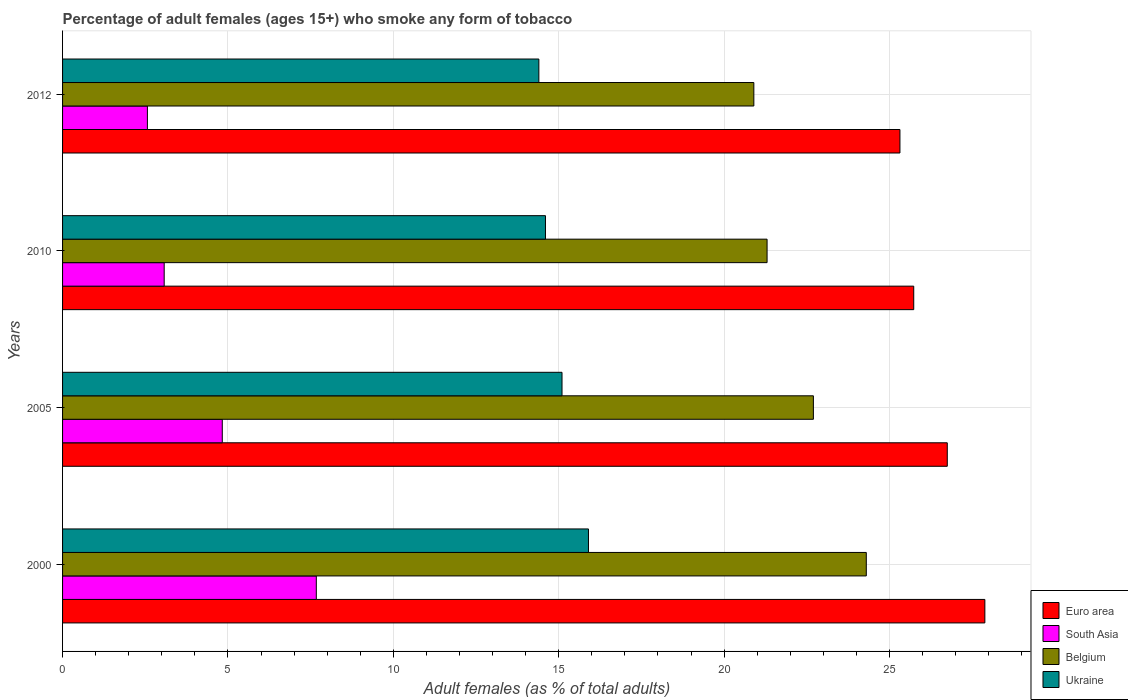How many different coloured bars are there?
Give a very brief answer. 4. How many groups of bars are there?
Offer a very short reply. 4. Are the number of bars per tick equal to the number of legend labels?
Provide a short and direct response. Yes. How many bars are there on the 3rd tick from the top?
Provide a succinct answer. 4. What is the label of the 4th group of bars from the top?
Provide a short and direct response. 2000. What is the percentage of adult females who smoke in Ukraine in 2012?
Provide a short and direct response. 14.4. Across all years, what is the maximum percentage of adult females who smoke in Belgium?
Your answer should be very brief. 24.3. In which year was the percentage of adult females who smoke in Belgium minimum?
Your answer should be compact. 2012. What is the difference between the percentage of adult females who smoke in Belgium in 2010 and the percentage of adult females who smoke in South Asia in 2005?
Your response must be concise. 16.47. What is the average percentage of adult females who smoke in Belgium per year?
Ensure brevity in your answer.  22.3. In the year 2000, what is the difference between the percentage of adult females who smoke in Belgium and percentage of adult females who smoke in South Asia?
Provide a succinct answer. 16.63. What is the ratio of the percentage of adult females who smoke in Ukraine in 2000 to that in 2005?
Offer a terse response. 1.05. Is the percentage of adult females who smoke in Euro area in 2000 less than that in 2012?
Provide a succinct answer. No. What is the difference between the highest and the second highest percentage of adult females who smoke in Euro area?
Give a very brief answer. 1.14. What is the difference between the highest and the lowest percentage of adult females who smoke in Belgium?
Your response must be concise. 3.4. In how many years, is the percentage of adult females who smoke in South Asia greater than the average percentage of adult females who smoke in South Asia taken over all years?
Your answer should be very brief. 2. Is the sum of the percentage of adult females who smoke in South Asia in 2005 and 2012 greater than the maximum percentage of adult females who smoke in Euro area across all years?
Give a very brief answer. No. What does the 3rd bar from the top in 2000 represents?
Your answer should be compact. South Asia. Is it the case that in every year, the sum of the percentage of adult females who smoke in Ukraine and percentage of adult females who smoke in Belgium is greater than the percentage of adult females who smoke in Euro area?
Offer a very short reply. Yes. How many bars are there?
Your answer should be very brief. 16. Are all the bars in the graph horizontal?
Make the answer very short. Yes. What is the difference between two consecutive major ticks on the X-axis?
Provide a short and direct response. 5. Are the values on the major ticks of X-axis written in scientific E-notation?
Your answer should be compact. No. Does the graph contain any zero values?
Ensure brevity in your answer.  No. Does the graph contain grids?
Offer a very short reply. Yes. Where does the legend appear in the graph?
Your answer should be compact. Bottom right. How are the legend labels stacked?
Ensure brevity in your answer.  Vertical. What is the title of the graph?
Keep it short and to the point. Percentage of adult females (ages 15+) who smoke any form of tobacco. Does "Bosnia and Herzegovina" appear as one of the legend labels in the graph?
Your answer should be compact. No. What is the label or title of the X-axis?
Ensure brevity in your answer.  Adult females (as % of total adults). What is the Adult females (as % of total adults) in Euro area in 2000?
Ensure brevity in your answer.  27.88. What is the Adult females (as % of total adults) in South Asia in 2000?
Provide a succinct answer. 7.67. What is the Adult females (as % of total adults) in Belgium in 2000?
Your answer should be compact. 24.3. What is the Adult females (as % of total adults) of Euro area in 2005?
Make the answer very short. 26.75. What is the Adult females (as % of total adults) of South Asia in 2005?
Your answer should be compact. 4.83. What is the Adult females (as % of total adults) in Belgium in 2005?
Make the answer very short. 22.7. What is the Adult females (as % of total adults) in Euro area in 2010?
Give a very brief answer. 25.73. What is the Adult females (as % of total adults) in South Asia in 2010?
Make the answer very short. 3.07. What is the Adult females (as % of total adults) of Belgium in 2010?
Offer a very short reply. 21.3. What is the Adult females (as % of total adults) in Euro area in 2012?
Your response must be concise. 25.32. What is the Adult females (as % of total adults) of South Asia in 2012?
Give a very brief answer. 2.56. What is the Adult females (as % of total adults) of Belgium in 2012?
Offer a very short reply. 20.9. What is the Adult females (as % of total adults) in Ukraine in 2012?
Provide a succinct answer. 14.4. Across all years, what is the maximum Adult females (as % of total adults) of Euro area?
Keep it short and to the point. 27.88. Across all years, what is the maximum Adult females (as % of total adults) of South Asia?
Provide a succinct answer. 7.67. Across all years, what is the maximum Adult females (as % of total adults) in Belgium?
Your response must be concise. 24.3. Across all years, what is the minimum Adult females (as % of total adults) in Euro area?
Provide a short and direct response. 25.32. Across all years, what is the minimum Adult females (as % of total adults) of South Asia?
Offer a very short reply. 2.56. Across all years, what is the minimum Adult females (as % of total adults) of Belgium?
Your answer should be very brief. 20.9. Across all years, what is the minimum Adult females (as % of total adults) of Ukraine?
Your response must be concise. 14.4. What is the total Adult females (as % of total adults) of Euro area in the graph?
Keep it short and to the point. 105.68. What is the total Adult females (as % of total adults) of South Asia in the graph?
Make the answer very short. 18.14. What is the total Adult females (as % of total adults) of Belgium in the graph?
Ensure brevity in your answer.  89.2. What is the difference between the Adult females (as % of total adults) of Euro area in 2000 and that in 2005?
Keep it short and to the point. 1.14. What is the difference between the Adult females (as % of total adults) in South Asia in 2000 and that in 2005?
Your answer should be very brief. 2.84. What is the difference between the Adult females (as % of total adults) in Belgium in 2000 and that in 2005?
Provide a short and direct response. 1.6. What is the difference between the Adult females (as % of total adults) in Euro area in 2000 and that in 2010?
Offer a terse response. 2.15. What is the difference between the Adult females (as % of total adults) in South Asia in 2000 and that in 2010?
Keep it short and to the point. 4.6. What is the difference between the Adult females (as % of total adults) in Belgium in 2000 and that in 2010?
Keep it short and to the point. 3. What is the difference between the Adult females (as % of total adults) in Euro area in 2000 and that in 2012?
Give a very brief answer. 2.57. What is the difference between the Adult females (as % of total adults) of South Asia in 2000 and that in 2012?
Your answer should be very brief. 5.11. What is the difference between the Adult females (as % of total adults) in Ukraine in 2000 and that in 2012?
Provide a short and direct response. 1.5. What is the difference between the Adult females (as % of total adults) in Euro area in 2005 and that in 2010?
Offer a very short reply. 1.01. What is the difference between the Adult females (as % of total adults) of South Asia in 2005 and that in 2010?
Provide a succinct answer. 1.76. What is the difference between the Adult females (as % of total adults) of Euro area in 2005 and that in 2012?
Give a very brief answer. 1.43. What is the difference between the Adult females (as % of total adults) of South Asia in 2005 and that in 2012?
Provide a succinct answer. 2.26. What is the difference between the Adult females (as % of total adults) in Euro area in 2010 and that in 2012?
Give a very brief answer. 0.42. What is the difference between the Adult females (as % of total adults) in South Asia in 2010 and that in 2012?
Give a very brief answer. 0.51. What is the difference between the Adult females (as % of total adults) of Ukraine in 2010 and that in 2012?
Your answer should be compact. 0.2. What is the difference between the Adult females (as % of total adults) in Euro area in 2000 and the Adult females (as % of total adults) in South Asia in 2005?
Your response must be concise. 23.06. What is the difference between the Adult females (as % of total adults) of Euro area in 2000 and the Adult females (as % of total adults) of Belgium in 2005?
Your answer should be very brief. 5.18. What is the difference between the Adult females (as % of total adults) in Euro area in 2000 and the Adult females (as % of total adults) in Ukraine in 2005?
Provide a short and direct response. 12.78. What is the difference between the Adult females (as % of total adults) in South Asia in 2000 and the Adult females (as % of total adults) in Belgium in 2005?
Provide a short and direct response. -15.03. What is the difference between the Adult females (as % of total adults) in South Asia in 2000 and the Adult females (as % of total adults) in Ukraine in 2005?
Provide a succinct answer. -7.43. What is the difference between the Adult females (as % of total adults) in Euro area in 2000 and the Adult females (as % of total adults) in South Asia in 2010?
Make the answer very short. 24.81. What is the difference between the Adult females (as % of total adults) in Euro area in 2000 and the Adult females (as % of total adults) in Belgium in 2010?
Your answer should be compact. 6.58. What is the difference between the Adult females (as % of total adults) of Euro area in 2000 and the Adult females (as % of total adults) of Ukraine in 2010?
Provide a succinct answer. 13.28. What is the difference between the Adult females (as % of total adults) of South Asia in 2000 and the Adult females (as % of total adults) of Belgium in 2010?
Your response must be concise. -13.63. What is the difference between the Adult females (as % of total adults) of South Asia in 2000 and the Adult females (as % of total adults) of Ukraine in 2010?
Provide a short and direct response. -6.93. What is the difference between the Adult females (as % of total adults) in Belgium in 2000 and the Adult females (as % of total adults) in Ukraine in 2010?
Your response must be concise. 9.7. What is the difference between the Adult females (as % of total adults) in Euro area in 2000 and the Adult females (as % of total adults) in South Asia in 2012?
Your answer should be compact. 25.32. What is the difference between the Adult females (as % of total adults) of Euro area in 2000 and the Adult females (as % of total adults) of Belgium in 2012?
Offer a very short reply. 6.98. What is the difference between the Adult females (as % of total adults) of Euro area in 2000 and the Adult females (as % of total adults) of Ukraine in 2012?
Provide a short and direct response. 13.48. What is the difference between the Adult females (as % of total adults) of South Asia in 2000 and the Adult females (as % of total adults) of Belgium in 2012?
Offer a very short reply. -13.23. What is the difference between the Adult females (as % of total adults) in South Asia in 2000 and the Adult females (as % of total adults) in Ukraine in 2012?
Make the answer very short. -6.73. What is the difference between the Adult females (as % of total adults) of Belgium in 2000 and the Adult females (as % of total adults) of Ukraine in 2012?
Provide a succinct answer. 9.9. What is the difference between the Adult females (as % of total adults) of Euro area in 2005 and the Adult females (as % of total adults) of South Asia in 2010?
Your answer should be very brief. 23.68. What is the difference between the Adult females (as % of total adults) in Euro area in 2005 and the Adult females (as % of total adults) in Belgium in 2010?
Your response must be concise. 5.45. What is the difference between the Adult females (as % of total adults) of Euro area in 2005 and the Adult females (as % of total adults) of Ukraine in 2010?
Provide a succinct answer. 12.15. What is the difference between the Adult females (as % of total adults) in South Asia in 2005 and the Adult females (as % of total adults) in Belgium in 2010?
Your answer should be compact. -16.47. What is the difference between the Adult females (as % of total adults) of South Asia in 2005 and the Adult females (as % of total adults) of Ukraine in 2010?
Offer a very short reply. -9.77. What is the difference between the Adult females (as % of total adults) in Euro area in 2005 and the Adult females (as % of total adults) in South Asia in 2012?
Ensure brevity in your answer.  24.18. What is the difference between the Adult females (as % of total adults) of Euro area in 2005 and the Adult females (as % of total adults) of Belgium in 2012?
Give a very brief answer. 5.85. What is the difference between the Adult females (as % of total adults) in Euro area in 2005 and the Adult females (as % of total adults) in Ukraine in 2012?
Give a very brief answer. 12.35. What is the difference between the Adult females (as % of total adults) in South Asia in 2005 and the Adult females (as % of total adults) in Belgium in 2012?
Offer a very short reply. -16.07. What is the difference between the Adult females (as % of total adults) in South Asia in 2005 and the Adult females (as % of total adults) in Ukraine in 2012?
Your answer should be very brief. -9.57. What is the difference between the Adult females (as % of total adults) of Euro area in 2010 and the Adult females (as % of total adults) of South Asia in 2012?
Your answer should be very brief. 23.17. What is the difference between the Adult females (as % of total adults) of Euro area in 2010 and the Adult females (as % of total adults) of Belgium in 2012?
Provide a short and direct response. 4.83. What is the difference between the Adult females (as % of total adults) in Euro area in 2010 and the Adult females (as % of total adults) in Ukraine in 2012?
Provide a succinct answer. 11.33. What is the difference between the Adult females (as % of total adults) in South Asia in 2010 and the Adult females (as % of total adults) in Belgium in 2012?
Keep it short and to the point. -17.83. What is the difference between the Adult females (as % of total adults) of South Asia in 2010 and the Adult females (as % of total adults) of Ukraine in 2012?
Provide a short and direct response. -11.33. What is the average Adult females (as % of total adults) in Euro area per year?
Offer a very short reply. 26.42. What is the average Adult females (as % of total adults) of South Asia per year?
Ensure brevity in your answer.  4.53. What is the average Adult females (as % of total adults) in Belgium per year?
Provide a short and direct response. 22.3. What is the average Adult females (as % of total adults) in Ukraine per year?
Your response must be concise. 15. In the year 2000, what is the difference between the Adult females (as % of total adults) in Euro area and Adult females (as % of total adults) in South Asia?
Keep it short and to the point. 20.21. In the year 2000, what is the difference between the Adult females (as % of total adults) in Euro area and Adult females (as % of total adults) in Belgium?
Your answer should be compact. 3.58. In the year 2000, what is the difference between the Adult females (as % of total adults) in Euro area and Adult females (as % of total adults) in Ukraine?
Your response must be concise. 11.98. In the year 2000, what is the difference between the Adult females (as % of total adults) of South Asia and Adult females (as % of total adults) of Belgium?
Give a very brief answer. -16.63. In the year 2000, what is the difference between the Adult females (as % of total adults) of South Asia and Adult females (as % of total adults) of Ukraine?
Your answer should be compact. -8.23. In the year 2000, what is the difference between the Adult females (as % of total adults) in Belgium and Adult females (as % of total adults) in Ukraine?
Your answer should be very brief. 8.4. In the year 2005, what is the difference between the Adult females (as % of total adults) in Euro area and Adult females (as % of total adults) in South Asia?
Ensure brevity in your answer.  21.92. In the year 2005, what is the difference between the Adult females (as % of total adults) in Euro area and Adult females (as % of total adults) in Belgium?
Offer a very short reply. 4.05. In the year 2005, what is the difference between the Adult females (as % of total adults) in Euro area and Adult females (as % of total adults) in Ukraine?
Your answer should be very brief. 11.65. In the year 2005, what is the difference between the Adult females (as % of total adults) in South Asia and Adult females (as % of total adults) in Belgium?
Offer a very short reply. -17.87. In the year 2005, what is the difference between the Adult females (as % of total adults) of South Asia and Adult females (as % of total adults) of Ukraine?
Give a very brief answer. -10.27. In the year 2005, what is the difference between the Adult females (as % of total adults) of Belgium and Adult females (as % of total adults) of Ukraine?
Make the answer very short. 7.6. In the year 2010, what is the difference between the Adult females (as % of total adults) in Euro area and Adult females (as % of total adults) in South Asia?
Provide a short and direct response. 22.66. In the year 2010, what is the difference between the Adult females (as % of total adults) of Euro area and Adult females (as % of total adults) of Belgium?
Offer a very short reply. 4.43. In the year 2010, what is the difference between the Adult females (as % of total adults) of Euro area and Adult females (as % of total adults) of Ukraine?
Your answer should be very brief. 11.13. In the year 2010, what is the difference between the Adult females (as % of total adults) of South Asia and Adult females (as % of total adults) of Belgium?
Your answer should be very brief. -18.23. In the year 2010, what is the difference between the Adult females (as % of total adults) of South Asia and Adult females (as % of total adults) of Ukraine?
Offer a terse response. -11.53. In the year 2010, what is the difference between the Adult females (as % of total adults) in Belgium and Adult females (as % of total adults) in Ukraine?
Offer a terse response. 6.7. In the year 2012, what is the difference between the Adult females (as % of total adults) in Euro area and Adult females (as % of total adults) in South Asia?
Offer a very short reply. 22.75. In the year 2012, what is the difference between the Adult females (as % of total adults) of Euro area and Adult females (as % of total adults) of Belgium?
Provide a succinct answer. 4.42. In the year 2012, what is the difference between the Adult females (as % of total adults) in Euro area and Adult females (as % of total adults) in Ukraine?
Keep it short and to the point. 10.92. In the year 2012, what is the difference between the Adult females (as % of total adults) of South Asia and Adult females (as % of total adults) of Belgium?
Offer a very short reply. -18.34. In the year 2012, what is the difference between the Adult females (as % of total adults) of South Asia and Adult females (as % of total adults) of Ukraine?
Provide a short and direct response. -11.84. What is the ratio of the Adult females (as % of total adults) of Euro area in 2000 to that in 2005?
Keep it short and to the point. 1.04. What is the ratio of the Adult females (as % of total adults) in South Asia in 2000 to that in 2005?
Ensure brevity in your answer.  1.59. What is the ratio of the Adult females (as % of total adults) of Belgium in 2000 to that in 2005?
Ensure brevity in your answer.  1.07. What is the ratio of the Adult females (as % of total adults) in Ukraine in 2000 to that in 2005?
Give a very brief answer. 1.05. What is the ratio of the Adult females (as % of total adults) in Euro area in 2000 to that in 2010?
Your answer should be very brief. 1.08. What is the ratio of the Adult females (as % of total adults) of South Asia in 2000 to that in 2010?
Keep it short and to the point. 2.5. What is the ratio of the Adult females (as % of total adults) in Belgium in 2000 to that in 2010?
Keep it short and to the point. 1.14. What is the ratio of the Adult females (as % of total adults) of Ukraine in 2000 to that in 2010?
Your answer should be very brief. 1.09. What is the ratio of the Adult females (as % of total adults) of Euro area in 2000 to that in 2012?
Give a very brief answer. 1.1. What is the ratio of the Adult females (as % of total adults) in South Asia in 2000 to that in 2012?
Ensure brevity in your answer.  2.99. What is the ratio of the Adult females (as % of total adults) of Belgium in 2000 to that in 2012?
Offer a terse response. 1.16. What is the ratio of the Adult females (as % of total adults) of Ukraine in 2000 to that in 2012?
Keep it short and to the point. 1.1. What is the ratio of the Adult females (as % of total adults) of Euro area in 2005 to that in 2010?
Provide a short and direct response. 1.04. What is the ratio of the Adult females (as % of total adults) of South Asia in 2005 to that in 2010?
Provide a short and direct response. 1.57. What is the ratio of the Adult females (as % of total adults) of Belgium in 2005 to that in 2010?
Your answer should be very brief. 1.07. What is the ratio of the Adult females (as % of total adults) in Ukraine in 2005 to that in 2010?
Your answer should be compact. 1.03. What is the ratio of the Adult females (as % of total adults) of Euro area in 2005 to that in 2012?
Provide a succinct answer. 1.06. What is the ratio of the Adult females (as % of total adults) in South Asia in 2005 to that in 2012?
Offer a very short reply. 1.88. What is the ratio of the Adult females (as % of total adults) of Belgium in 2005 to that in 2012?
Make the answer very short. 1.09. What is the ratio of the Adult females (as % of total adults) of Ukraine in 2005 to that in 2012?
Your answer should be compact. 1.05. What is the ratio of the Adult females (as % of total adults) in Euro area in 2010 to that in 2012?
Offer a very short reply. 1.02. What is the ratio of the Adult females (as % of total adults) of South Asia in 2010 to that in 2012?
Make the answer very short. 1.2. What is the ratio of the Adult females (as % of total adults) of Belgium in 2010 to that in 2012?
Your response must be concise. 1.02. What is the ratio of the Adult females (as % of total adults) in Ukraine in 2010 to that in 2012?
Your response must be concise. 1.01. What is the difference between the highest and the second highest Adult females (as % of total adults) of Euro area?
Your answer should be very brief. 1.14. What is the difference between the highest and the second highest Adult females (as % of total adults) of South Asia?
Offer a terse response. 2.84. What is the difference between the highest and the second highest Adult females (as % of total adults) in Belgium?
Your answer should be compact. 1.6. What is the difference between the highest and the lowest Adult females (as % of total adults) of Euro area?
Make the answer very short. 2.57. What is the difference between the highest and the lowest Adult females (as % of total adults) of South Asia?
Make the answer very short. 5.11. What is the difference between the highest and the lowest Adult females (as % of total adults) in Belgium?
Offer a very short reply. 3.4. 